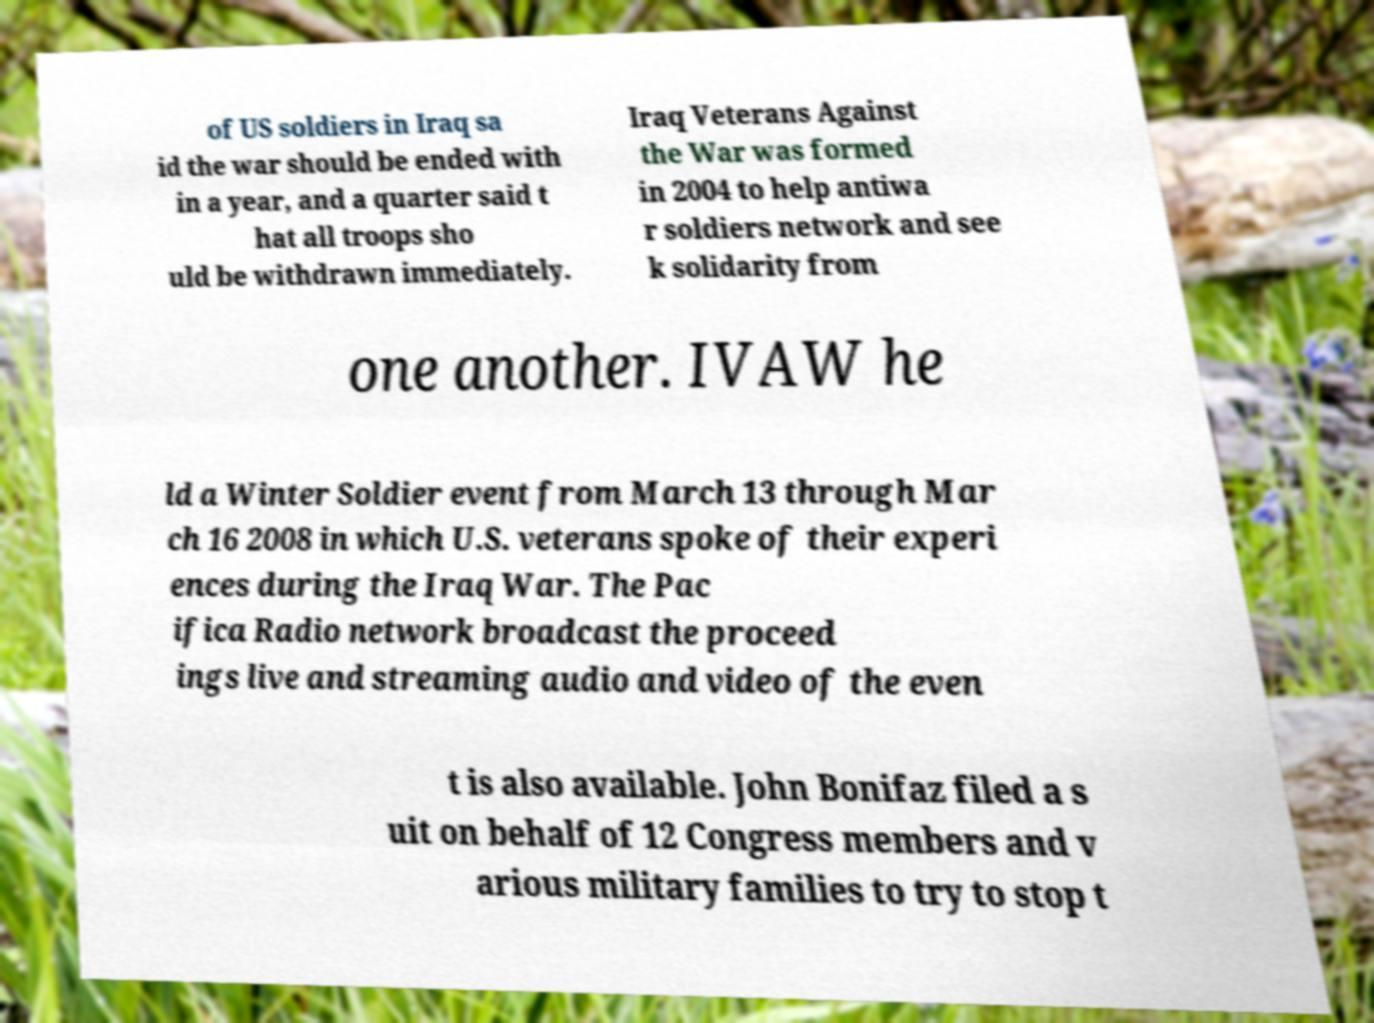Please read and relay the text visible in this image. What does it say? of US soldiers in Iraq sa id the war should be ended with in a year, and a quarter said t hat all troops sho uld be withdrawn immediately. Iraq Veterans Against the War was formed in 2004 to help antiwa r soldiers network and see k solidarity from one another. IVAW he ld a Winter Soldier event from March 13 through Mar ch 16 2008 in which U.S. veterans spoke of their experi ences during the Iraq War. The Pac ifica Radio network broadcast the proceed ings live and streaming audio and video of the even t is also available. John Bonifaz filed a s uit on behalf of 12 Congress members and v arious military families to try to stop t 